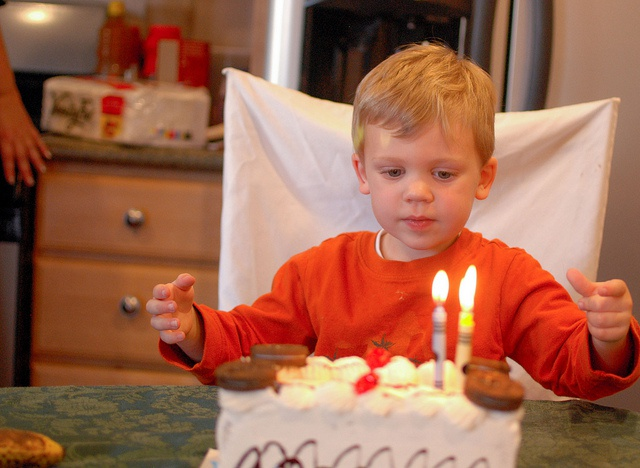Describe the objects in this image and their specific colors. I can see people in black, red, and brown tones, dining table in black, olive, tan, and gray tones, chair in black, tan, and lightgray tones, cake in black, tan, brown, and maroon tones, and cake in black, gray, tan, and brown tones in this image. 